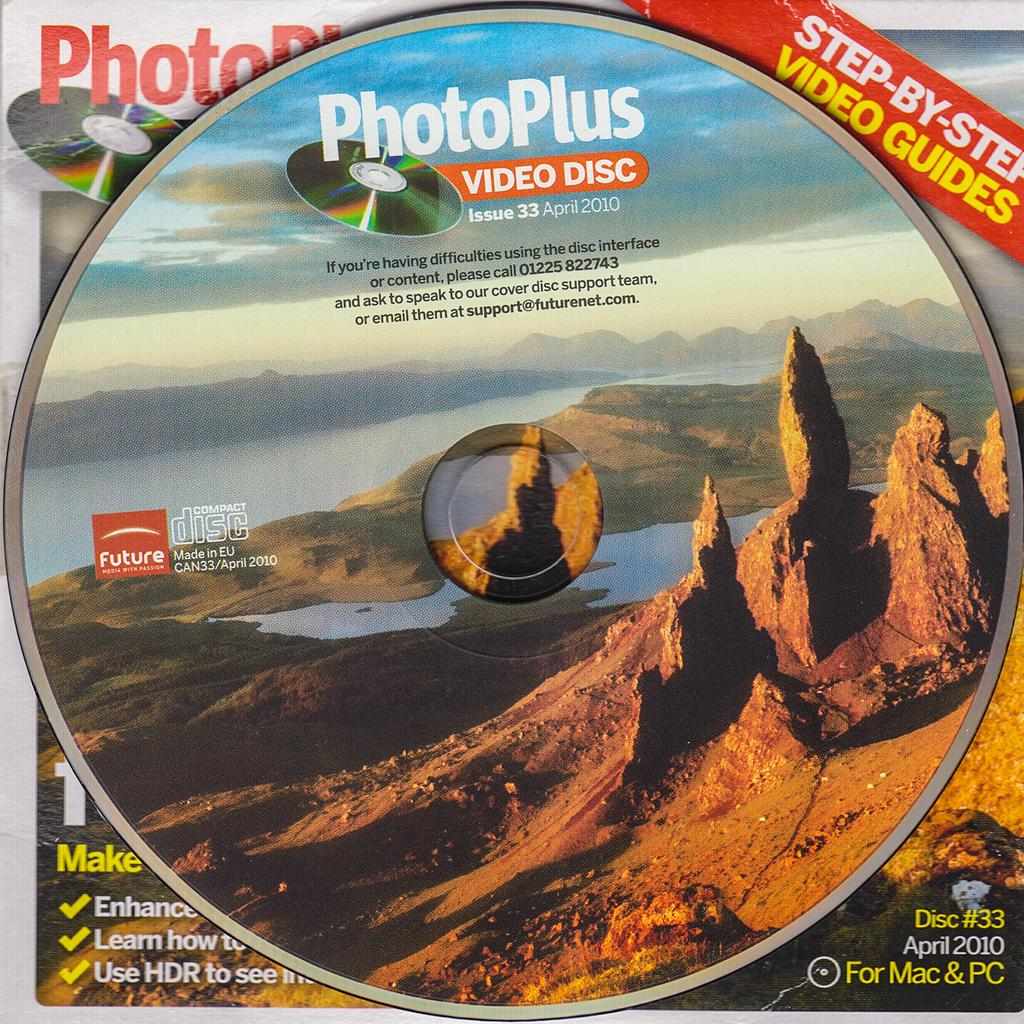<image>
Summarize the visual content of the image. A PhotoPlus Video Disc features an Arizona mountain scene, complete with mountains and a lake. 